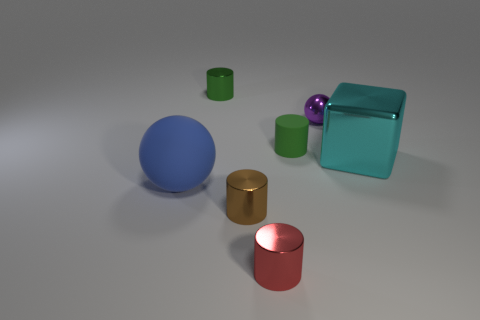How would you describe the texture of the objects in the image? The objects displayed in the image have a smooth and glossy texture, which is enhanced by the light reflection that gives them a slightly shiny appearance. 